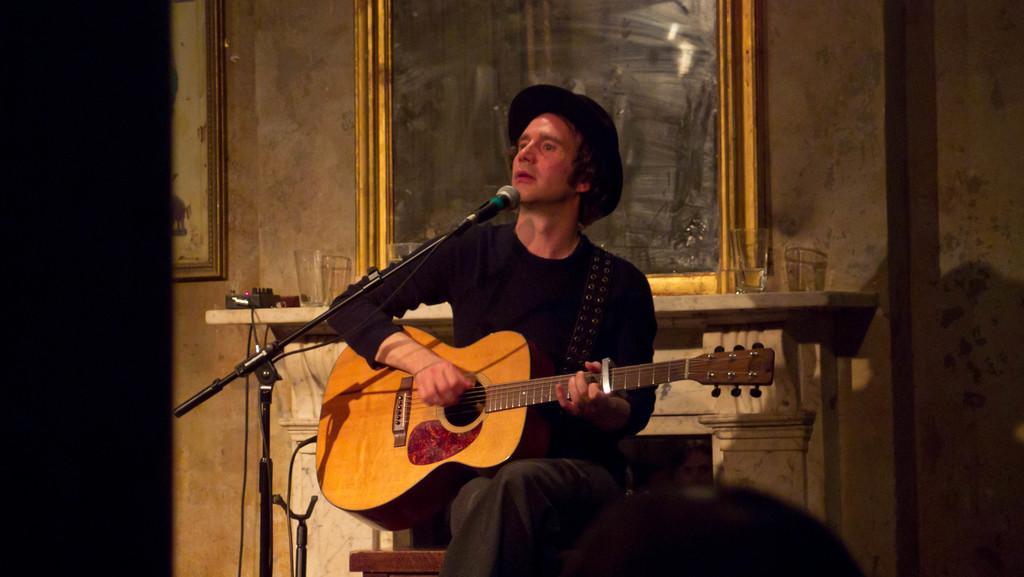How would you summarize this image in a sentence or two? This person is sitting on a chair and playing guitar in-front of mic. This person wore black t-shirt and hat. On this table there are glasses. A mirror on wall. A picture on wall. 